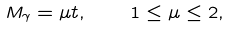<formula> <loc_0><loc_0><loc_500><loc_500>M _ { \gamma } = \mu t , \quad 1 \leq \mu \leq 2 ,</formula> 